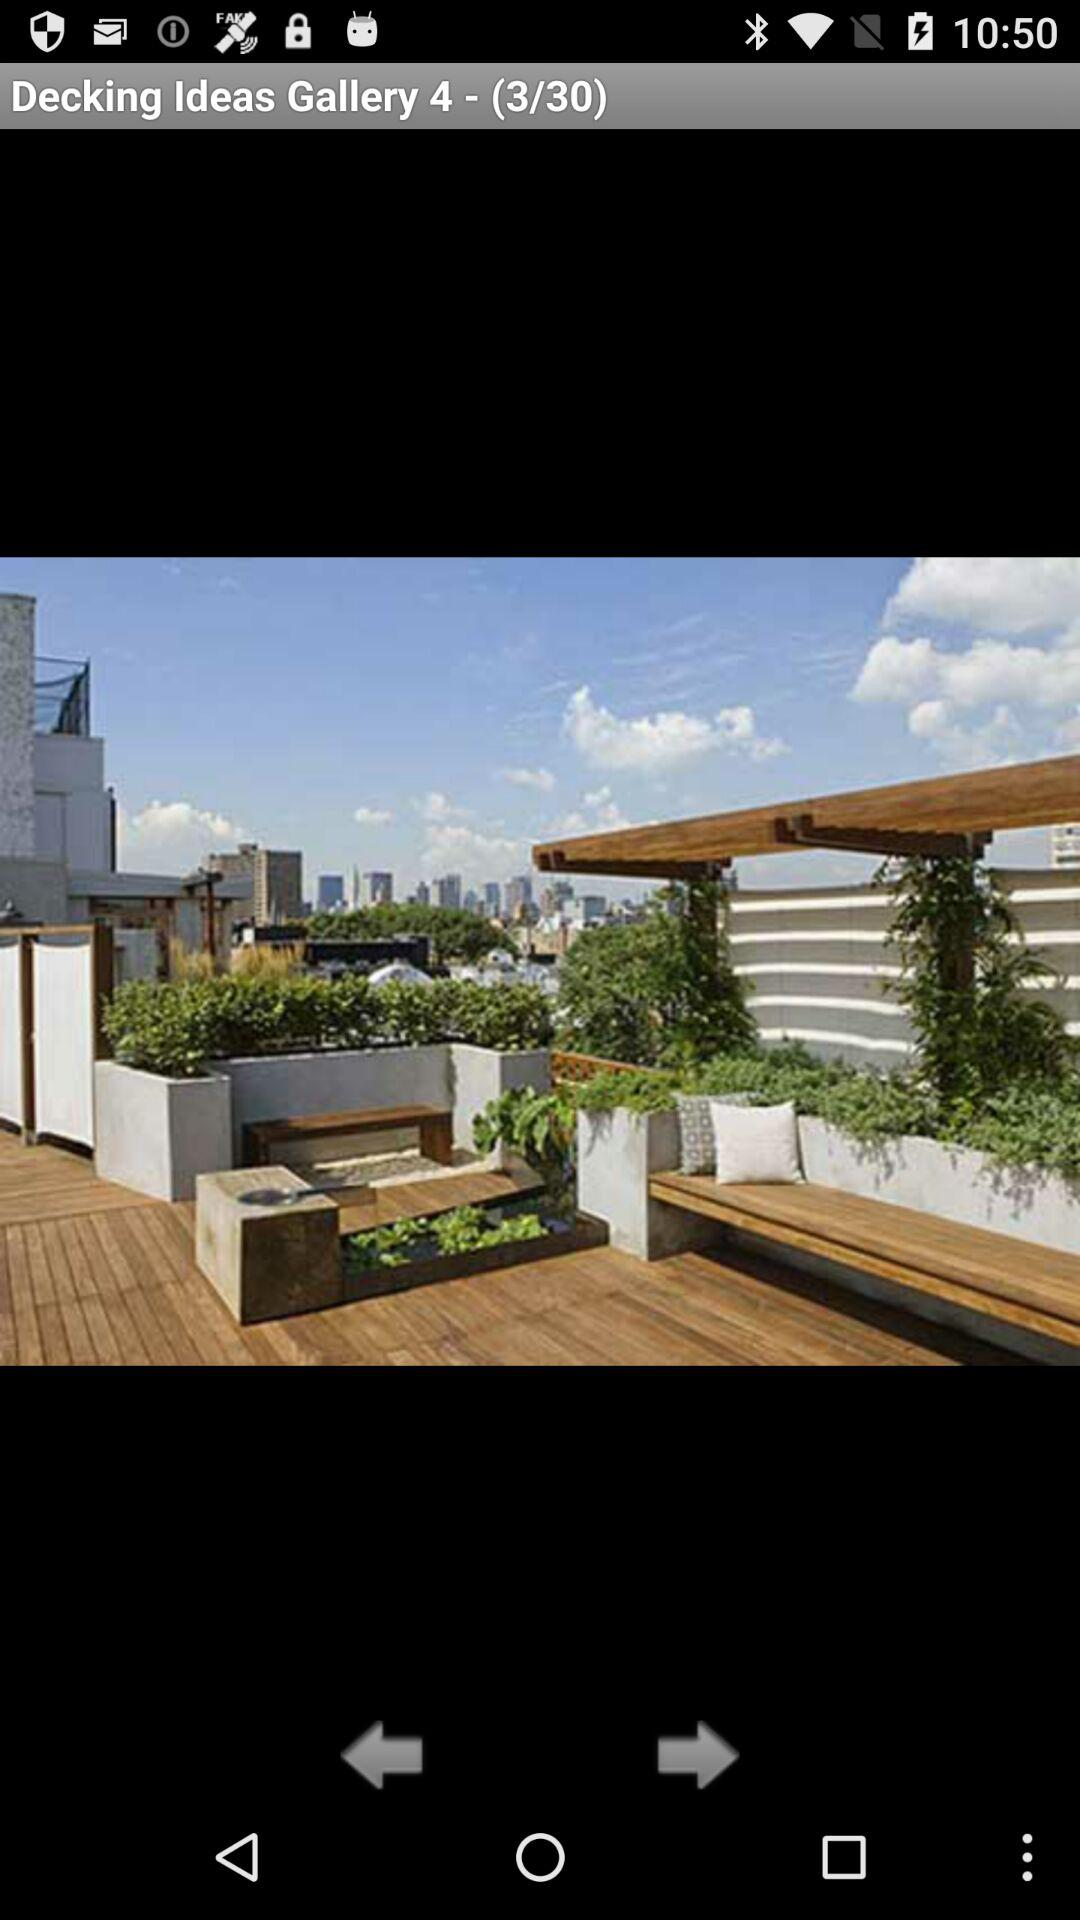What is the gallery name? The gallery name is "Decking Ideas Gallery 4". 